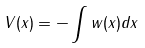<formula> <loc_0><loc_0><loc_500><loc_500>V ( x ) = - \int w ( x ) d x</formula> 